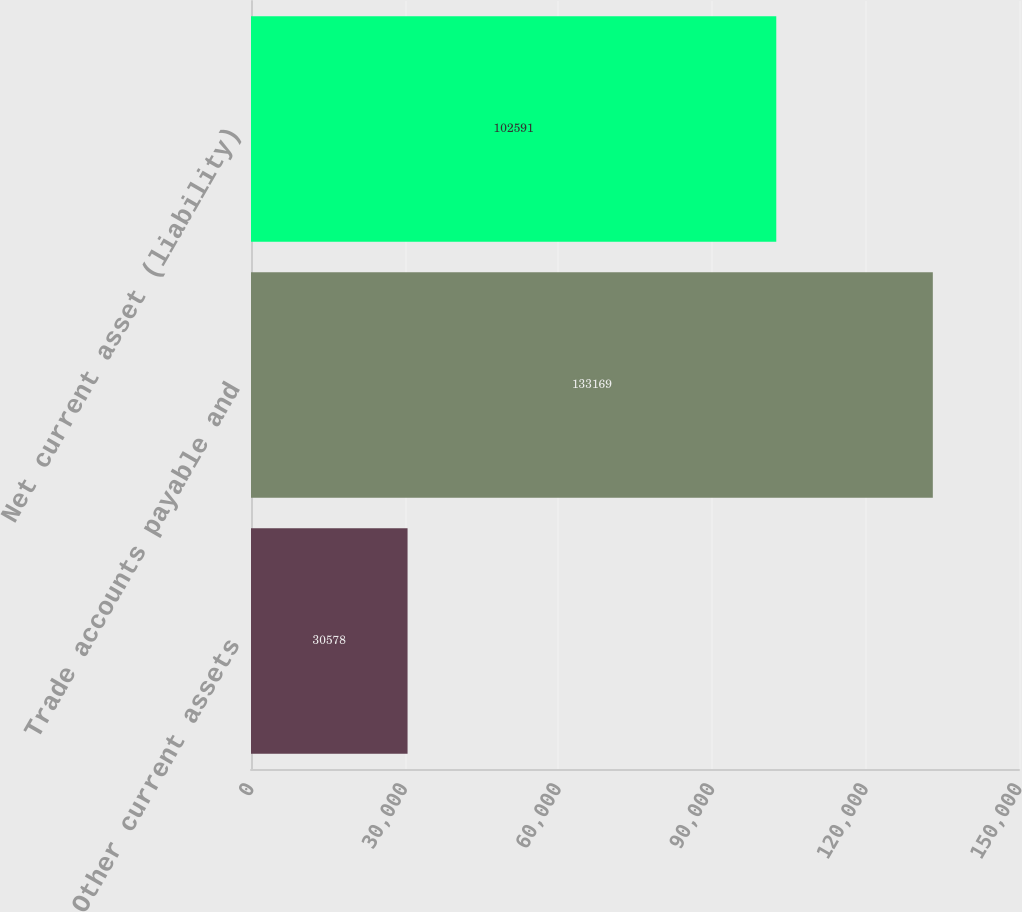Convert chart to OTSL. <chart><loc_0><loc_0><loc_500><loc_500><bar_chart><fcel>Other current assets<fcel>Trade accounts payable and<fcel>Net current asset (liability)<nl><fcel>30578<fcel>133169<fcel>102591<nl></chart> 